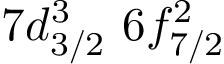Convert formula to latex. <formula><loc_0><loc_0><loc_500><loc_500>7 d _ { 3 / 2 } ^ { 3 } \, 6 f _ { 7 / 2 } ^ { 2 } \,</formula> 